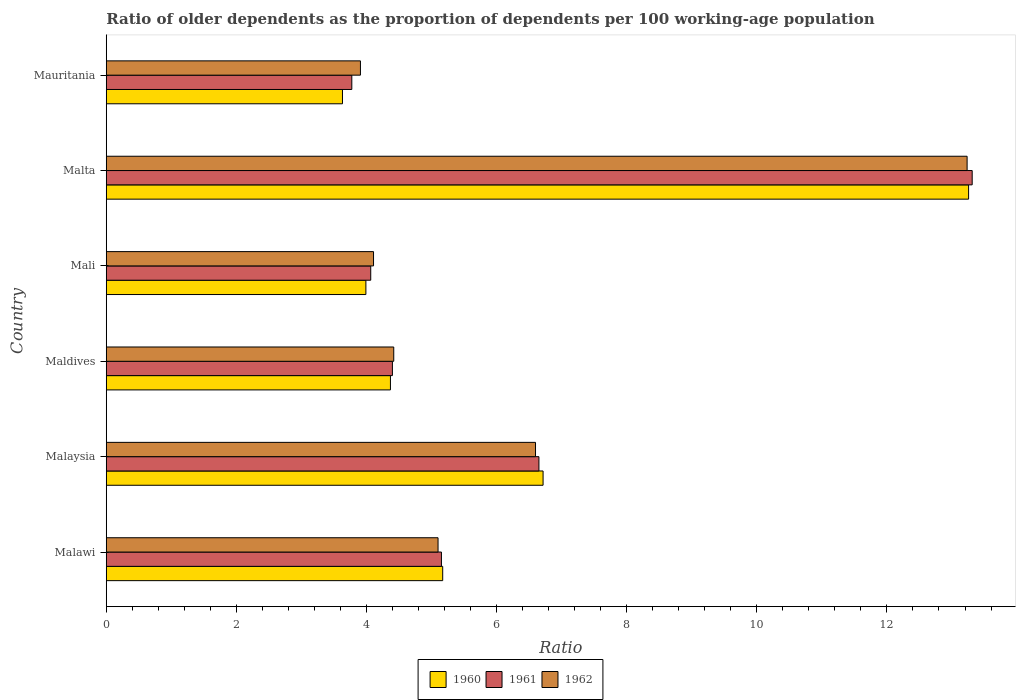How many different coloured bars are there?
Your answer should be very brief. 3. How many bars are there on the 2nd tick from the top?
Offer a very short reply. 3. How many bars are there on the 6th tick from the bottom?
Offer a terse response. 3. What is the label of the 5th group of bars from the top?
Give a very brief answer. Malaysia. What is the age dependency ratio(old) in 1962 in Malawi?
Your answer should be compact. 5.1. Across all countries, what is the maximum age dependency ratio(old) in 1961?
Give a very brief answer. 13.31. Across all countries, what is the minimum age dependency ratio(old) in 1962?
Offer a very short reply. 3.91. In which country was the age dependency ratio(old) in 1961 maximum?
Offer a very short reply. Malta. In which country was the age dependency ratio(old) in 1962 minimum?
Make the answer very short. Mauritania. What is the total age dependency ratio(old) in 1961 in the graph?
Provide a short and direct response. 37.35. What is the difference between the age dependency ratio(old) in 1961 in Maldives and that in Malta?
Make the answer very short. -8.91. What is the difference between the age dependency ratio(old) in 1962 in Maldives and the age dependency ratio(old) in 1961 in Mali?
Keep it short and to the point. 0.35. What is the average age dependency ratio(old) in 1962 per country?
Give a very brief answer. 6.23. What is the difference between the age dependency ratio(old) in 1960 and age dependency ratio(old) in 1962 in Malta?
Ensure brevity in your answer.  0.02. What is the ratio of the age dependency ratio(old) in 1962 in Malawi to that in Mali?
Provide a short and direct response. 1.24. What is the difference between the highest and the second highest age dependency ratio(old) in 1960?
Keep it short and to the point. 6.54. What is the difference between the highest and the lowest age dependency ratio(old) in 1961?
Keep it short and to the point. 9.54. In how many countries, is the age dependency ratio(old) in 1962 greater than the average age dependency ratio(old) in 1962 taken over all countries?
Your response must be concise. 2. What does the 2nd bar from the top in Mauritania represents?
Give a very brief answer. 1961. Are the values on the major ticks of X-axis written in scientific E-notation?
Offer a terse response. No. Does the graph contain grids?
Give a very brief answer. No. How many legend labels are there?
Your answer should be compact. 3. How are the legend labels stacked?
Ensure brevity in your answer.  Horizontal. What is the title of the graph?
Ensure brevity in your answer.  Ratio of older dependents as the proportion of dependents per 100 working-age population. What is the label or title of the X-axis?
Offer a terse response. Ratio. What is the label or title of the Y-axis?
Offer a terse response. Country. What is the Ratio of 1960 in Malawi?
Your answer should be compact. 5.17. What is the Ratio in 1961 in Malawi?
Ensure brevity in your answer.  5.15. What is the Ratio in 1962 in Malawi?
Offer a terse response. 5.1. What is the Ratio in 1960 in Malaysia?
Keep it short and to the point. 6.71. What is the Ratio of 1961 in Malaysia?
Provide a short and direct response. 6.65. What is the Ratio in 1962 in Malaysia?
Your answer should be very brief. 6.6. What is the Ratio in 1960 in Maldives?
Make the answer very short. 4.37. What is the Ratio in 1961 in Maldives?
Offer a terse response. 4.4. What is the Ratio in 1962 in Maldives?
Provide a short and direct response. 4.42. What is the Ratio in 1960 in Mali?
Your answer should be very brief. 3.99. What is the Ratio in 1961 in Mali?
Provide a succinct answer. 4.07. What is the Ratio in 1962 in Mali?
Your response must be concise. 4.11. What is the Ratio of 1960 in Malta?
Make the answer very short. 13.26. What is the Ratio of 1961 in Malta?
Your answer should be very brief. 13.31. What is the Ratio in 1962 in Malta?
Keep it short and to the point. 13.23. What is the Ratio of 1960 in Mauritania?
Ensure brevity in your answer.  3.63. What is the Ratio of 1961 in Mauritania?
Your answer should be very brief. 3.77. What is the Ratio of 1962 in Mauritania?
Ensure brevity in your answer.  3.91. Across all countries, what is the maximum Ratio of 1960?
Provide a succinct answer. 13.26. Across all countries, what is the maximum Ratio in 1961?
Give a very brief answer. 13.31. Across all countries, what is the maximum Ratio in 1962?
Your response must be concise. 13.23. Across all countries, what is the minimum Ratio in 1960?
Your answer should be very brief. 3.63. Across all countries, what is the minimum Ratio in 1961?
Ensure brevity in your answer.  3.77. Across all countries, what is the minimum Ratio of 1962?
Offer a very short reply. 3.91. What is the total Ratio in 1960 in the graph?
Make the answer very short. 37.13. What is the total Ratio of 1961 in the graph?
Make the answer very short. 37.35. What is the total Ratio of 1962 in the graph?
Offer a terse response. 37.37. What is the difference between the Ratio in 1960 in Malawi and that in Malaysia?
Make the answer very short. -1.54. What is the difference between the Ratio in 1961 in Malawi and that in Malaysia?
Offer a terse response. -1.5. What is the difference between the Ratio of 1962 in Malawi and that in Malaysia?
Offer a very short reply. -1.5. What is the difference between the Ratio of 1960 in Malawi and that in Maldives?
Give a very brief answer. 0.8. What is the difference between the Ratio in 1961 in Malawi and that in Maldives?
Offer a terse response. 0.75. What is the difference between the Ratio in 1962 in Malawi and that in Maldives?
Offer a terse response. 0.68. What is the difference between the Ratio in 1960 in Malawi and that in Mali?
Give a very brief answer. 1.18. What is the difference between the Ratio of 1961 in Malawi and that in Mali?
Your answer should be very brief. 1.09. What is the difference between the Ratio of 1962 in Malawi and that in Mali?
Offer a very short reply. 0.99. What is the difference between the Ratio in 1960 in Malawi and that in Malta?
Give a very brief answer. -8.08. What is the difference between the Ratio of 1961 in Malawi and that in Malta?
Provide a short and direct response. -8.16. What is the difference between the Ratio in 1962 in Malawi and that in Malta?
Provide a succinct answer. -8.13. What is the difference between the Ratio of 1960 in Malawi and that in Mauritania?
Ensure brevity in your answer.  1.54. What is the difference between the Ratio in 1961 in Malawi and that in Mauritania?
Make the answer very short. 1.38. What is the difference between the Ratio in 1962 in Malawi and that in Mauritania?
Your answer should be compact. 1.19. What is the difference between the Ratio of 1960 in Malaysia and that in Maldives?
Your answer should be very brief. 2.35. What is the difference between the Ratio in 1961 in Malaysia and that in Maldives?
Provide a succinct answer. 2.25. What is the difference between the Ratio in 1962 in Malaysia and that in Maldives?
Provide a short and direct response. 2.18. What is the difference between the Ratio in 1960 in Malaysia and that in Mali?
Keep it short and to the point. 2.72. What is the difference between the Ratio in 1961 in Malaysia and that in Mali?
Keep it short and to the point. 2.59. What is the difference between the Ratio in 1962 in Malaysia and that in Mali?
Your answer should be compact. 2.49. What is the difference between the Ratio in 1960 in Malaysia and that in Malta?
Provide a short and direct response. -6.54. What is the difference between the Ratio of 1961 in Malaysia and that in Malta?
Make the answer very short. -6.66. What is the difference between the Ratio of 1962 in Malaysia and that in Malta?
Offer a very short reply. -6.63. What is the difference between the Ratio in 1960 in Malaysia and that in Mauritania?
Make the answer very short. 3.08. What is the difference between the Ratio of 1961 in Malaysia and that in Mauritania?
Ensure brevity in your answer.  2.88. What is the difference between the Ratio in 1962 in Malaysia and that in Mauritania?
Keep it short and to the point. 2.69. What is the difference between the Ratio of 1960 in Maldives and that in Mali?
Your answer should be very brief. 0.38. What is the difference between the Ratio in 1961 in Maldives and that in Mali?
Provide a short and direct response. 0.33. What is the difference between the Ratio of 1962 in Maldives and that in Mali?
Ensure brevity in your answer.  0.31. What is the difference between the Ratio of 1960 in Maldives and that in Malta?
Keep it short and to the point. -8.89. What is the difference between the Ratio of 1961 in Maldives and that in Malta?
Ensure brevity in your answer.  -8.91. What is the difference between the Ratio in 1962 in Maldives and that in Malta?
Make the answer very short. -8.81. What is the difference between the Ratio of 1960 in Maldives and that in Mauritania?
Make the answer very short. 0.74. What is the difference between the Ratio in 1961 in Maldives and that in Mauritania?
Provide a short and direct response. 0.62. What is the difference between the Ratio in 1962 in Maldives and that in Mauritania?
Offer a terse response. 0.51. What is the difference between the Ratio in 1960 in Mali and that in Malta?
Offer a terse response. -9.26. What is the difference between the Ratio of 1961 in Mali and that in Malta?
Your answer should be compact. -9.25. What is the difference between the Ratio of 1962 in Mali and that in Malta?
Ensure brevity in your answer.  -9.12. What is the difference between the Ratio in 1960 in Mali and that in Mauritania?
Make the answer very short. 0.36. What is the difference between the Ratio of 1961 in Mali and that in Mauritania?
Keep it short and to the point. 0.29. What is the difference between the Ratio in 1962 in Mali and that in Mauritania?
Offer a terse response. 0.2. What is the difference between the Ratio in 1960 in Malta and that in Mauritania?
Give a very brief answer. 9.62. What is the difference between the Ratio in 1961 in Malta and that in Mauritania?
Make the answer very short. 9.54. What is the difference between the Ratio in 1962 in Malta and that in Mauritania?
Your answer should be compact. 9.33. What is the difference between the Ratio of 1960 in Malawi and the Ratio of 1961 in Malaysia?
Provide a succinct answer. -1.48. What is the difference between the Ratio of 1960 in Malawi and the Ratio of 1962 in Malaysia?
Keep it short and to the point. -1.43. What is the difference between the Ratio of 1961 in Malawi and the Ratio of 1962 in Malaysia?
Ensure brevity in your answer.  -1.45. What is the difference between the Ratio in 1960 in Malawi and the Ratio in 1961 in Maldives?
Offer a terse response. 0.77. What is the difference between the Ratio in 1960 in Malawi and the Ratio in 1962 in Maldives?
Provide a succinct answer. 0.75. What is the difference between the Ratio of 1961 in Malawi and the Ratio of 1962 in Maldives?
Make the answer very short. 0.73. What is the difference between the Ratio of 1960 in Malawi and the Ratio of 1961 in Mali?
Your answer should be very brief. 1.11. What is the difference between the Ratio in 1960 in Malawi and the Ratio in 1962 in Mali?
Offer a terse response. 1.06. What is the difference between the Ratio of 1961 in Malawi and the Ratio of 1962 in Mali?
Give a very brief answer. 1.04. What is the difference between the Ratio of 1960 in Malawi and the Ratio of 1961 in Malta?
Your answer should be very brief. -8.14. What is the difference between the Ratio in 1960 in Malawi and the Ratio in 1962 in Malta?
Ensure brevity in your answer.  -8.06. What is the difference between the Ratio in 1961 in Malawi and the Ratio in 1962 in Malta?
Your answer should be compact. -8.08. What is the difference between the Ratio of 1960 in Malawi and the Ratio of 1961 in Mauritania?
Keep it short and to the point. 1.4. What is the difference between the Ratio in 1960 in Malawi and the Ratio in 1962 in Mauritania?
Your answer should be very brief. 1.26. What is the difference between the Ratio in 1961 in Malawi and the Ratio in 1962 in Mauritania?
Ensure brevity in your answer.  1.25. What is the difference between the Ratio in 1960 in Malaysia and the Ratio in 1961 in Maldives?
Offer a very short reply. 2.32. What is the difference between the Ratio of 1960 in Malaysia and the Ratio of 1962 in Maldives?
Provide a short and direct response. 2.3. What is the difference between the Ratio of 1961 in Malaysia and the Ratio of 1962 in Maldives?
Your answer should be very brief. 2.23. What is the difference between the Ratio of 1960 in Malaysia and the Ratio of 1961 in Mali?
Your answer should be very brief. 2.65. What is the difference between the Ratio of 1960 in Malaysia and the Ratio of 1962 in Mali?
Your answer should be very brief. 2.61. What is the difference between the Ratio of 1961 in Malaysia and the Ratio of 1962 in Mali?
Provide a short and direct response. 2.54. What is the difference between the Ratio in 1960 in Malaysia and the Ratio in 1961 in Malta?
Offer a very short reply. -6.6. What is the difference between the Ratio in 1960 in Malaysia and the Ratio in 1962 in Malta?
Your response must be concise. -6.52. What is the difference between the Ratio in 1961 in Malaysia and the Ratio in 1962 in Malta?
Offer a very short reply. -6.58. What is the difference between the Ratio of 1960 in Malaysia and the Ratio of 1961 in Mauritania?
Provide a short and direct response. 2.94. What is the difference between the Ratio in 1960 in Malaysia and the Ratio in 1962 in Mauritania?
Your response must be concise. 2.81. What is the difference between the Ratio in 1961 in Malaysia and the Ratio in 1962 in Mauritania?
Keep it short and to the point. 2.74. What is the difference between the Ratio in 1960 in Maldives and the Ratio in 1961 in Mali?
Provide a succinct answer. 0.3. What is the difference between the Ratio of 1960 in Maldives and the Ratio of 1962 in Mali?
Offer a very short reply. 0.26. What is the difference between the Ratio of 1961 in Maldives and the Ratio of 1962 in Mali?
Offer a terse response. 0.29. What is the difference between the Ratio of 1960 in Maldives and the Ratio of 1961 in Malta?
Provide a short and direct response. -8.94. What is the difference between the Ratio in 1960 in Maldives and the Ratio in 1962 in Malta?
Provide a succinct answer. -8.86. What is the difference between the Ratio of 1961 in Maldives and the Ratio of 1962 in Malta?
Make the answer very short. -8.83. What is the difference between the Ratio in 1960 in Maldives and the Ratio in 1961 in Mauritania?
Ensure brevity in your answer.  0.59. What is the difference between the Ratio of 1960 in Maldives and the Ratio of 1962 in Mauritania?
Provide a short and direct response. 0.46. What is the difference between the Ratio in 1961 in Maldives and the Ratio in 1962 in Mauritania?
Provide a short and direct response. 0.49. What is the difference between the Ratio of 1960 in Mali and the Ratio of 1961 in Malta?
Provide a succinct answer. -9.32. What is the difference between the Ratio in 1960 in Mali and the Ratio in 1962 in Malta?
Provide a short and direct response. -9.24. What is the difference between the Ratio in 1961 in Mali and the Ratio in 1962 in Malta?
Ensure brevity in your answer.  -9.17. What is the difference between the Ratio of 1960 in Mali and the Ratio of 1961 in Mauritania?
Give a very brief answer. 0.22. What is the difference between the Ratio in 1960 in Mali and the Ratio in 1962 in Mauritania?
Ensure brevity in your answer.  0.08. What is the difference between the Ratio in 1961 in Mali and the Ratio in 1962 in Mauritania?
Offer a very short reply. 0.16. What is the difference between the Ratio in 1960 in Malta and the Ratio in 1961 in Mauritania?
Give a very brief answer. 9.48. What is the difference between the Ratio in 1960 in Malta and the Ratio in 1962 in Mauritania?
Keep it short and to the point. 9.35. What is the difference between the Ratio of 1961 in Malta and the Ratio of 1962 in Mauritania?
Provide a short and direct response. 9.4. What is the average Ratio of 1960 per country?
Provide a succinct answer. 6.19. What is the average Ratio of 1961 per country?
Offer a very short reply. 6.23. What is the average Ratio of 1962 per country?
Offer a very short reply. 6.23. What is the difference between the Ratio in 1960 and Ratio in 1961 in Malawi?
Your answer should be compact. 0.02. What is the difference between the Ratio in 1960 and Ratio in 1962 in Malawi?
Offer a very short reply. 0.07. What is the difference between the Ratio in 1961 and Ratio in 1962 in Malawi?
Your response must be concise. 0.05. What is the difference between the Ratio in 1960 and Ratio in 1961 in Malaysia?
Keep it short and to the point. 0.06. What is the difference between the Ratio of 1960 and Ratio of 1962 in Malaysia?
Provide a succinct answer. 0.12. What is the difference between the Ratio in 1961 and Ratio in 1962 in Malaysia?
Ensure brevity in your answer.  0.05. What is the difference between the Ratio of 1960 and Ratio of 1961 in Maldives?
Your answer should be very brief. -0.03. What is the difference between the Ratio in 1960 and Ratio in 1962 in Maldives?
Your answer should be compact. -0.05. What is the difference between the Ratio in 1961 and Ratio in 1962 in Maldives?
Offer a terse response. -0.02. What is the difference between the Ratio of 1960 and Ratio of 1961 in Mali?
Provide a succinct answer. -0.07. What is the difference between the Ratio of 1960 and Ratio of 1962 in Mali?
Give a very brief answer. -0.12. What is the difference between the Ratio in 1961 and Ratio in 1962 in Mali?
Provide a succinct answer. -0.04. What is the difference between the Ratio of 1960 and Ratio of 1961 in Malta?
Provide a short and direct response. -0.06. What is the difference between the Ratio of 1960 and Ratio of 1962 in Malta?
Provide a succinct answer. 0.02. What is the difference between the Ratio of 1961 and Ratio of 1962 in Malta?
Keep it short and to the point. 0.08. What is the difference between the Ratio of 1960 and Ratio of 1961 in Mauritania?
Your answer should be very brief. -0.14. What is the difference between the Ratio in 1960 and Ratio in 1962 in Mauritania?
Your answer should be very brief. -0.28. What is the difference between the Ratio of 1961 and Ratio of 1962 in Mauritania?
Your answer should be very brief. -0.13. What is the ratio of the Ratio of 1960 in Malawi to that in Malaysia?
Give a very brief answer. 0.77. What is the ratio of the Ratio of 1961 in Malawi to that in Malaysia?
Provide a short and direct response. 0.77. What is the ratio of the Ratio in 1962 in Malawi to that in Malaysia?
Give a very brief answer. 0.77. What is the ratio of the Ratio of 1960 in Malawi to that in Maldives?
Provide a succinct answer. 1.18. What is the ratio of the Ratio in 1961 in Malawi to that in Maldives?
Keep it short and to the point. 1.17. What is the ratio of the Ratio of 1962 in Malawi to that in Maldives?
Your answer should be very brief. 1.15. What is the ratio of the Ratio in 1960 in Malawi to that in Mali?
Provide a short and direct response. 1.3. What is the ratio of the Ratio in 1961 in Malawi to that in Mali?
Keep it short and to the point. 1.27. What is the ratio of the Ratio in 1962 in Malawi to that in Mali?
Provide a succinct answer. 1.24. What is the ratio of the Ratio in 1960 in Malawi to that in Malta?
Your response must be concise. 0.39. What is the ratio of the Ratio in 1961 in Malawi to that in Malta?
Give a very brief answer. 0.39. What is the ratio of the Ratio in 1962 in Malawi to that in Malta?
Give a very brief answer. 0.39. What is the ratio of the Ratio in 1960 in Malawi to that in Mauritania?
Offer a very short reply. 1.42. What is the ratio of the Ratio of 1961 in Malawi to that in Mauritania?
Provide a succinct answer. 1.36. What is the ratio of the Ratio of 1962 in Malawi to that in Mauritania?
Offer a very short reply. 1.31. What is the ratio of the Ratio in 1960 in Malaysia to that in Maldives?
Your answer should be very brief. 1.54. What is the ratio of the Ratio of 1961 in Malaysia to that in Maldives?
Your answer should be compact. 1.51. What is the ratio of the Ratio in 1962 in Malaysia to that in Maldives?
Provide a short and direct response. 1.49. What is the ratio of the Ratio in 1960 in Malaysia to that in Mali?
Ensure brevity in your answer.  1.68. What is the ratio of the Ratio in 1961 in Malaysia to that in Mali?
Offer a terse response. 1.64. What is the ratio of the Ratio in 1962 in Malaysia to that in Mali?
Keep it short and to the point. 1.61. What is the ratio of the Ratio of 1960 in Malaysia to that in Malta?
Ensure brevity in your answer.  0.51. What is the ratio of the Ratio in 1961 in Malaysia to that in Malta?
Ensure brevity in your answer.  0.5. What is the ratio of the Ratio in 1962 in Malaysia to that in Malta?
Make the answer very short. 0.5. What is the ratio of the Ratio of 1960 in Malaysia to that in Mauritania?
Offer a terse response. 1.85. What is the ratio of the Ratio in 1961 in Malaysia to that in Mauritania?
Provide a succinct answer. 1.76. What is the ratio of the Ratio in 1962 in Malaysia to that in Mauritania?
Your response must be concise. 1.69. What is the ratio of the Ratio of 1960 in Maldives to that in Mali?
Make the answer very short. 1.09. What is the ratio of the Ratio in 1961 in Maldives to that in Mali?
Your response must be concise. 1.08. What is the ratio of the Ratio in 1962 in Maldives to that in Mali?
Provide a short and direct response. 1.08. What is the ratio of the Ratio of 1960 in Maldives to that in Malta?
Keep it short and to the point. 0.33. What is the ratio of the Ratio of 1961 in Maldives to that in Malta?
Your answer should be compact. 0.33. What is the ratio of the Ratio of 1962 in Maldives to that in Malta?
Ensure brevity in your answer.  0.33. What is the ratio of the Ratio of 1960 in Maldives to that in Mauritania?
Your answer should be compact. 1.2. What is the ratio of the Ratio in 1961 in Maldives to that in Mauritania?
Provide a short and direct response. 1.17. What is the ratio of the Ratio of 1962 in Maldives to that in Mauritania?
Offer a terse response. 1.13. What is the ratio of the Ratio of 1960 in Mali to that in Malta?
Your response must be concise. 0.3. What is the ratio of the Ratio of 1961 in Mali to that in Malta?
Offer a very short reply. 0.31. What is the ratio of the Ratio in 1962 in Mali to that in Malta?
Ensure brevity in your answer.  0.31. What is the ratio of the Ratio in 1960 in Mali to that in Mauritania?
Keep it short and to the point. 1.1. What is the ratio of the Ratio of 1961 in Mali to that in Mauritania?
Your answer should be compact. 1.08. What is the ratio of the Ratio in 1962 in Mali to that in Mauritania?
Your answer should be compact. 1.05. What is the ratio of the Ratio in 1960 in Malta to that in Mauritania?
Your answer should be compact. 3.65. What is the ratio of the Ratio in 1961 in Malta to that in Mauritania?
Offer a very short reply. 3.53. What is the ratio of the Ratio of 1962 in Malta to that in Mauritania?
Provide a short and direct response. 3.39. What is the difference between the highest and the second highest Ratio of 1960?
Keep it short and to the point. 6.54. What is the difference between the highest and the second highest Ratio in 1961?
Your response must be concise. 6.66. What is the difference between the highest and the second highest Ratio in 1962?
Give a very brief answer. 6.63. What is the difference between the highest and the lowest Ratio in 1960?
Keep it short and to the point. 9.62. What is the difference between the highest and the lowest Ratio in 1961?
Provide a short and direct response. 9.54. What is the difference between the highest and the lowest Ratio in 1962?
Keep it short and to the point. 9.33. 